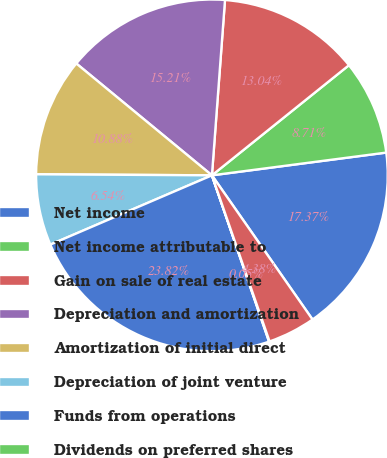<chart> <loc_0><loc_0><loc_500><loc_500><pie_chart><fcel>Net income<fcel>Net income attributable to<fcel>Gain on sale of real estate<fcel>Depreciation and amortization<fcel>Amortization of initial direct<fcel>Depreciation of joint venture<fcel>Funds from operations<fcel>Dividends on preferred shares<fcel>Income attributable to<nl><fcel>17.37%<fcel>8.71%<fcel>13.04%<fcel>15.21%<fcel>10.88%<fcel>6.54%<fcel>23.82%<fcel>0.05%<fcel>4.38%<nl></chart> 